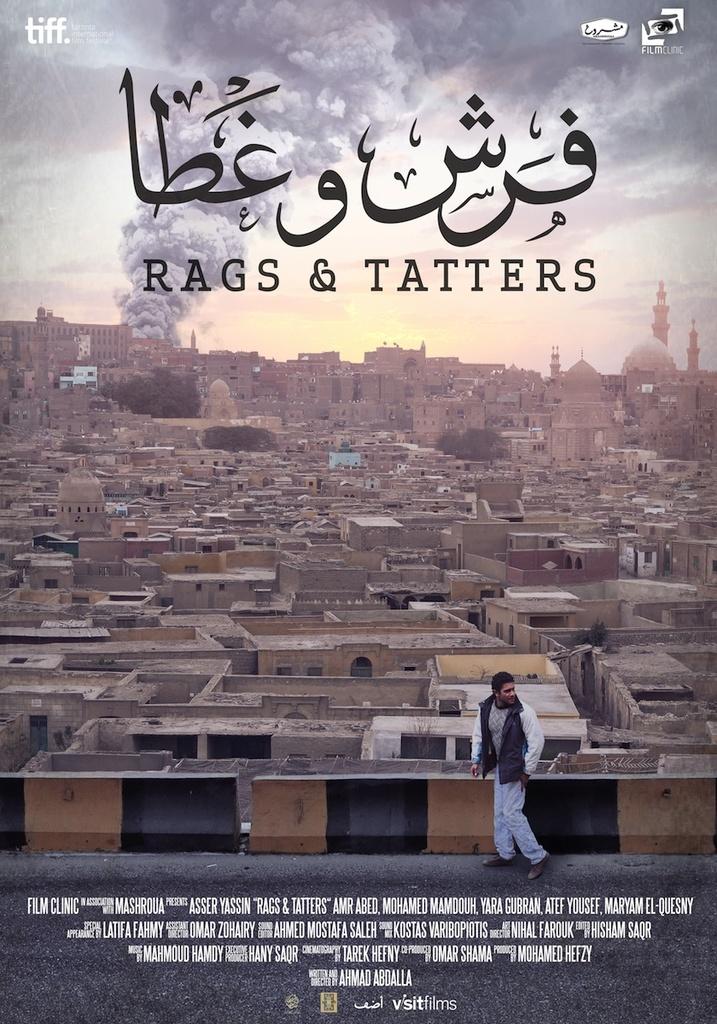What's the tagline?
Give a very brief answer. Rags & tatters. Is asser in this?
Your answer should be compact. Yes. 